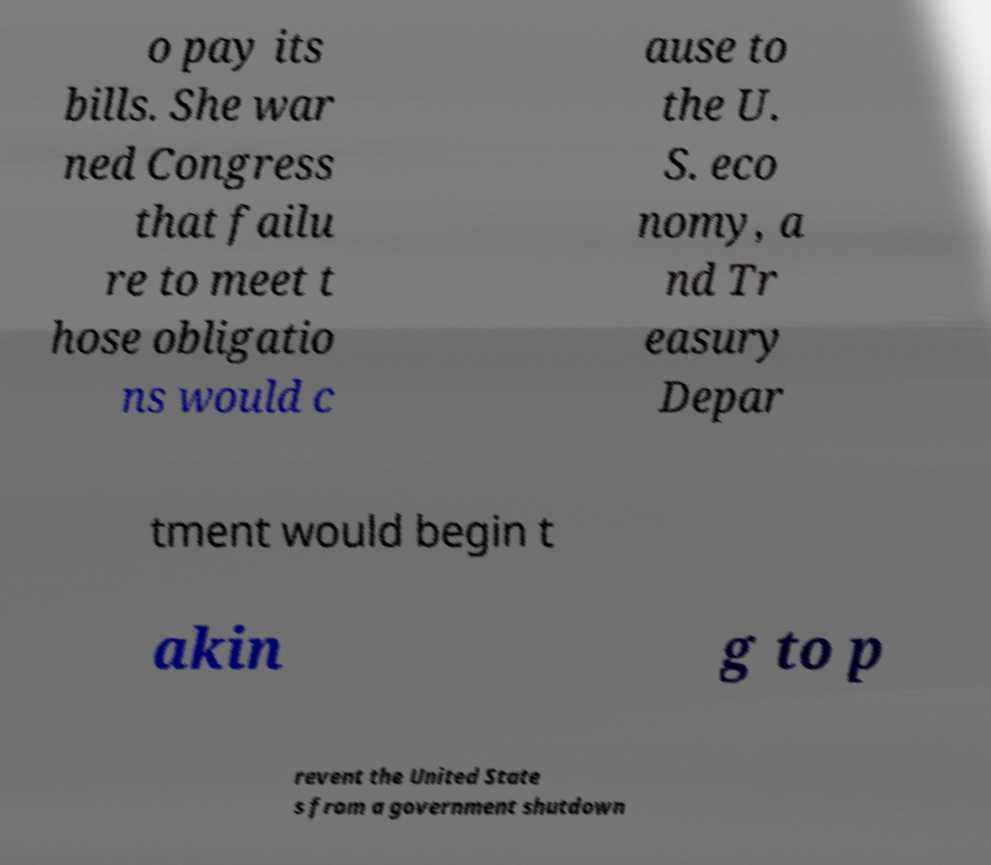What messages or text are displayed in this image? I need them in a readable, typed format. o pay its bills. She war ned Congress that failu re to meet t hose obligatio ns would c ause to the U. S. eco nomy, a nd Tr easury Depar tment would begin t akin g to p revent the United State s from a government shutdown 